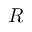Convert formula to latex. <formula><loc_0><loc_0><loc_500><loc_500>R</formula> 